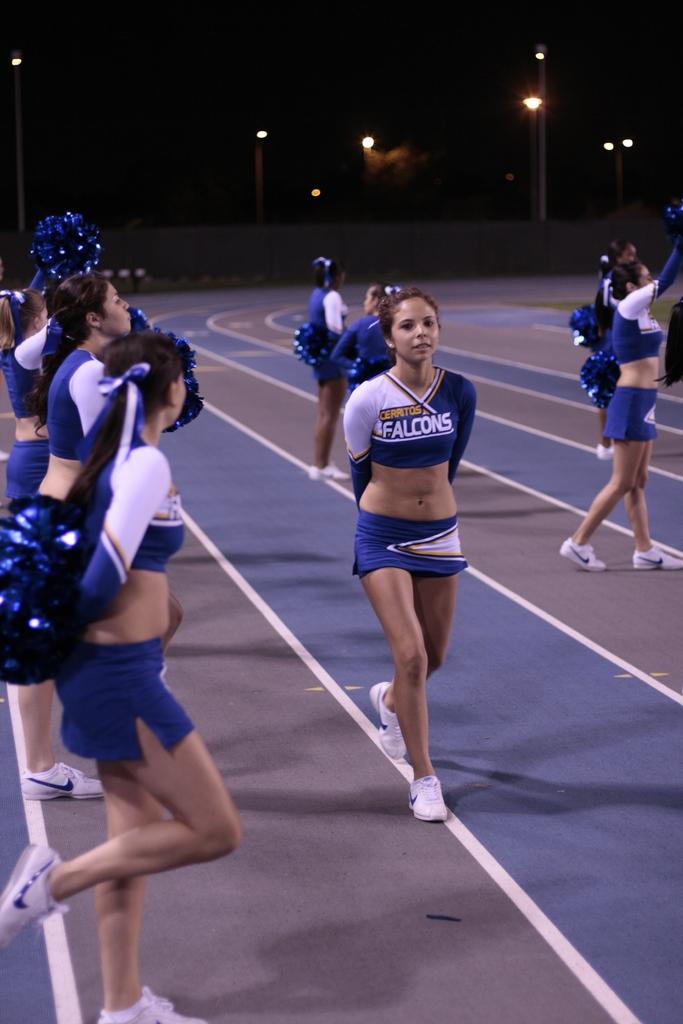What city is this cheerleader from?
Offer a terse response. Cerritos. 